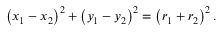<formula> <loc_0><loc_0><loc_500><loc_500>\left ( x _ { 1 } - x _ { 2 } \right ) ^ { 2 } + \left ( y _ { 1 } - y _ { 2 } \right ) ^ { 2 } = \left ( r _ { 1 } + r _ { 2 } \right ) ^ { 2 } .</formula> 